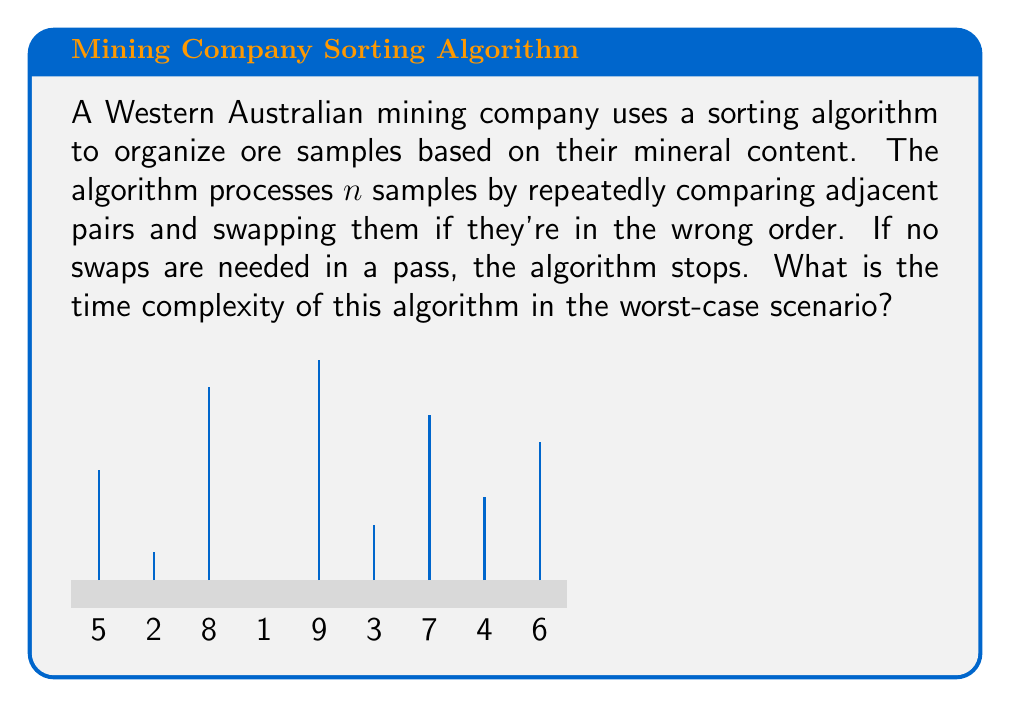Can you solve this math problem? Let's analyze this algorithm step-by-step:

1) The algorithm described is known as Bubble Sort, commonly used for its simplicity.

2) In the worst-case scenario, the array is in reverse order, and we need to make the maximum number of comparisons and swaps.

3) For $n$ elements:
   - First pass: $(n-1)$ comparisons
   - Second pass: $(n-2)$ comparisons
   - Third pass: $(n-3)$ comparisons
   ...
   - Last pass: $1$ comparison

4) Total number of comparisons:
   $$(n-1) + (n-2) + (n-3) + ... + 2 + 1 = \frac{n(n-1)}{2}$$

5) This sum is derived from the arithmetic series formula: $\sum_{i=1}^{n-1} i = \frac{n(n-1)}{2}$

6) In Big O notation, we ignore constants and lower-order terms. $\frac{n(n-1)}{2}$ simplifies to $\frac{n^2}{2} - \frac{n}{2}$

7) Therefore, the time complexity is $O(n^2)$

This quadratic time complexity makes Bubble Sort inefficient for large datasets, but it's simple to implement and can be useful for small sets of data or in educational contexts.
Answer: $O(n^2)$ 